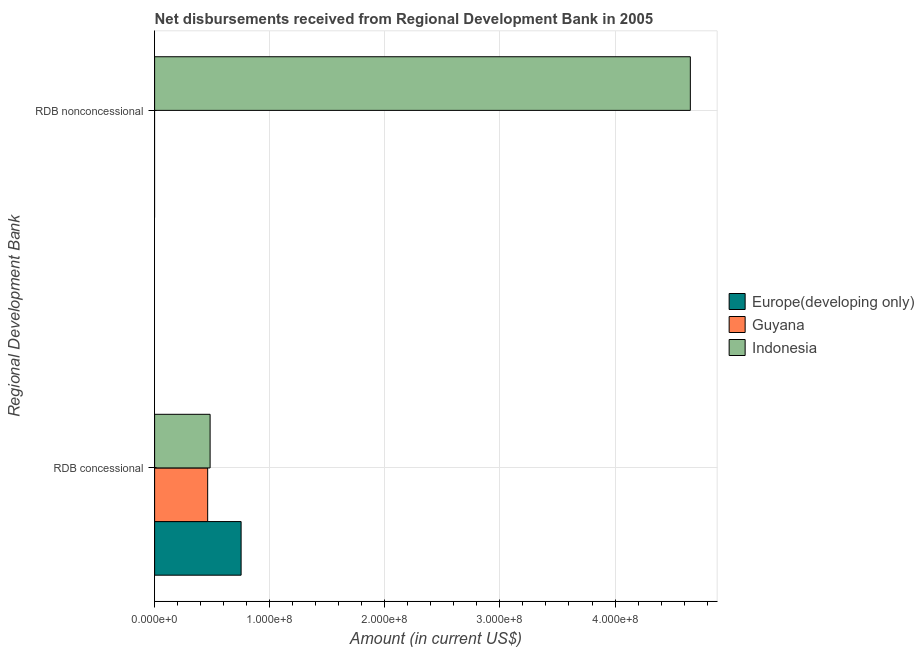How many different coloured bars are there?
Give a very brief answer. 3. Are the number of bars on each tick of the Y-axis equal?
Your answer should be very brief. No. How many bars are there on the 2nd tick from the bottom?
Keep it short and to the point. 1. What is the label of the 2nd group of bars from the top?
Provide a succinct answer. RDB concessional. What is the net concessional disbursements from rdb in Guyana?
Your answer should be compact. 4.61e+07. Across all countries, what is the maximum net non concessional disbursements from rdb?
Give a very brief answer. 4.65e+08. In which country was the net non concessional disbursements from rdb maximum?
Your answer should be compact. Indonesia. What is the total net concessional disbursements from rdb in the graph?
Make the answer very short. 1.69e+08. What is the difference between the net concessional disbursements from rdb in Europe(developing only) and that in Indonesia?
Keep it short and to the point. 2.69e+07. What is the difference between the net non concessional disbursements from rdb in Europe(developing only) and the net concessional disbursements from rdb in Guyana?
Offer a very short reply. -4.61e+07. What is the average net non concessional disbursements from rdb per country?
Offer a very short reply. 1.55e+08. What is the difference between the net non concessional disbursements from rdb and net concessional disbursements from rdb in Indonesia?
Keep it short and to the point. 4.17e+08. What is the ratio of the net concessional disbursements from rdb in Europe(developing only) to that in Indonesia?
Give a very brief answer. 1.56. How many bars are there?
Keep it short and to the point. 4. Are all the bars in the graph horizontal?
Offer a terse response. Yes. What is the difference between two consecutive major ticks on the X-axis?
Keep it short and to the point. 1.00e+08. Does the graph contain grids?
Give a very brief answer. Yes. How are the legend labels stacked?
Give a very brief answer. Vertical. What is the title of the graph?
Offer a very short reply. Net disbursements received from Regional Development Bank in 2005. What is the label or title of the X-axis?
Make the answer very short. Amount (in current US$). What is the label or title of the Y-axis?
Make the answer very short. Regional Development Bank. What is the Amount (in current US$) in Europe(developing only) in RDB concessional?
Offer a very short reply. 7.52e+07. What is the Amount (in current US$) in Guyana in RDB concessional?
Your answer should be very brief. 4.61e+07. What is the Amount (in current US$) of Indonesia in RDB concessional?
Keep it short and to the point. 4.82e+07. What is the Amount (in current US$) of Indonesia in RDB nonconcessional?
Ensure brevity in your answer.  4.65e+08. Across all Regional Development Bank, what is the maximum Amount (in current US$) in Europe(developing only)?
Offer a terse response. 7.52e+07. Across all Regional Development Bank, what is the maximum Amount (in current US$) of Guyana?
Ensure brevity in your answer.  4.61e+07. Across all Regional Development Bank, what is the maximum Amount (in current US$) in Indonesia?
Provide a succinct answer. 4.65e+08. Across all Regional Development Bank, what is the minimum Amount (in current US$) of Guyana?
Make the answer very short. 0. Across all Regional Development Bank, what is the minimum Amount (in current US$) in Indonesia?
Your response must be concise. 4.82e+07. What is the total Amount (in current US$) of Europe(developing only) in the graph?
Your answer should be compact. 7.52e+07. What is the total Amount (in current US$) in Guyana in the graph?
Offer a terse response. 4.61e+07. What is the total Amount (in current US$) of Indonesia in the graph?
Give a very brief answer. 5.14e+08. What is the difference between the Amount (in current US$) of Indonesia in RDB concessional and that in RDB nonconcessional?
Keep it short and to the point. -4.17e+08. What is the difference between the Amount (in current US$) of Europe(developing only) in RDB concessional and the Amount (in current US$) of Indonesia in RDB nonconcessional?
Make the answer very short. -3.90e+08. What is the difference between the Amount (in current US$) in Guyana in RDB concessional and the Amount (in current US$) in Indonesia in RDB nonconcessional?
Keep it short and to the point. -4.19e+08. What is the average Amount (in current US$) in Europe(developing only) per Regional Development Bank?
Ensure brevity in your answer.  3.76e+07. What is the average Amount (in current US$) in Guyana per Regional Development Bank?
Provide a succinct answer. 2.31e+07. What is the average Amount (in current US$) in Indonesia per Regional Development Bank?
Provide a succinct answer. 2.57e+08. What is the difference between the Amount (in current US$) in Europe(developing only) and Amount (in current US$) in Guyana in RDB concessional?
Your answer should be very brief. 2.90e+07. What is the difference between the Amount (in current US$) in Europe(developing only) and Amount (in current US$) in Indonesia in RDB concessional?
Ensure brevity in your answer.  2.69e+07. What is the difference between the Amount (in current US$) of Guyana and Amount (in current US$) of Indonesia in RDB concessional?
Make the answer very short. -2.11e+06. What is the ratio of the Amount (in current US$) in Indonesia in RDB concessional to that in RDB nonconcessional?
Offer a very short reply. 0.1. What is the difference between the highest and the second highest Amount (in current US$) in Indonesia?
Offer a terse response. 4.17e+08. What is the difference between the highest and the lowest Amount (in current US$) in Europe(developing only)?
Your answer should be very brief. 7.52e+07. What is the difference between the highest and the lowest Amount (in current US$) in Guyana?
Offer a terse response. 4.61e+07. What is the difference between the highest and the lowest Amount (in current US$) in Indonesia?
Make the answer very short. 4.17e+08. 